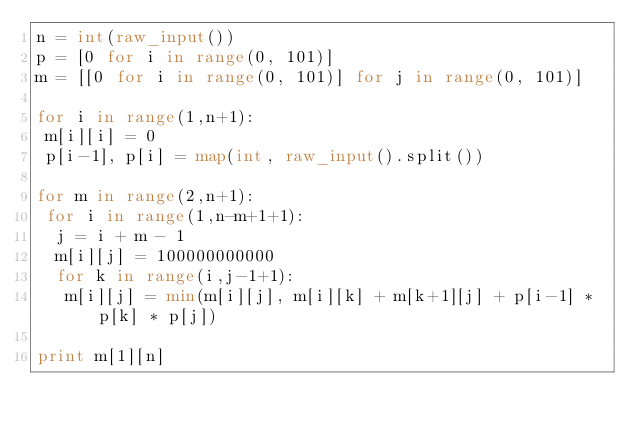Convert code to text. <code><loc_0><loc_0><loc_500><loc_500><_Python_>n = int(raw_input())
p = [0 for i in range(0, 101)]
m = [[0 for i in range(0, 101)] for j in range(0, 101)]

for i in range(1,n+1):
 m[i][i] = 0
 p[i-1], p[i] = map(int, raw_input().split())

for m in range(2,n+1):
 for i in range(1,n-m+1+1):
  j = i + m - 1
  m[i][j] = 100000000000
  for k in range(i,j-1+1):
   m[i][j] = min(m[i][j], m[i][k] + m[k+1][j] + p[i-1] * p[k] * p[j])

print m[1][n]</code> 